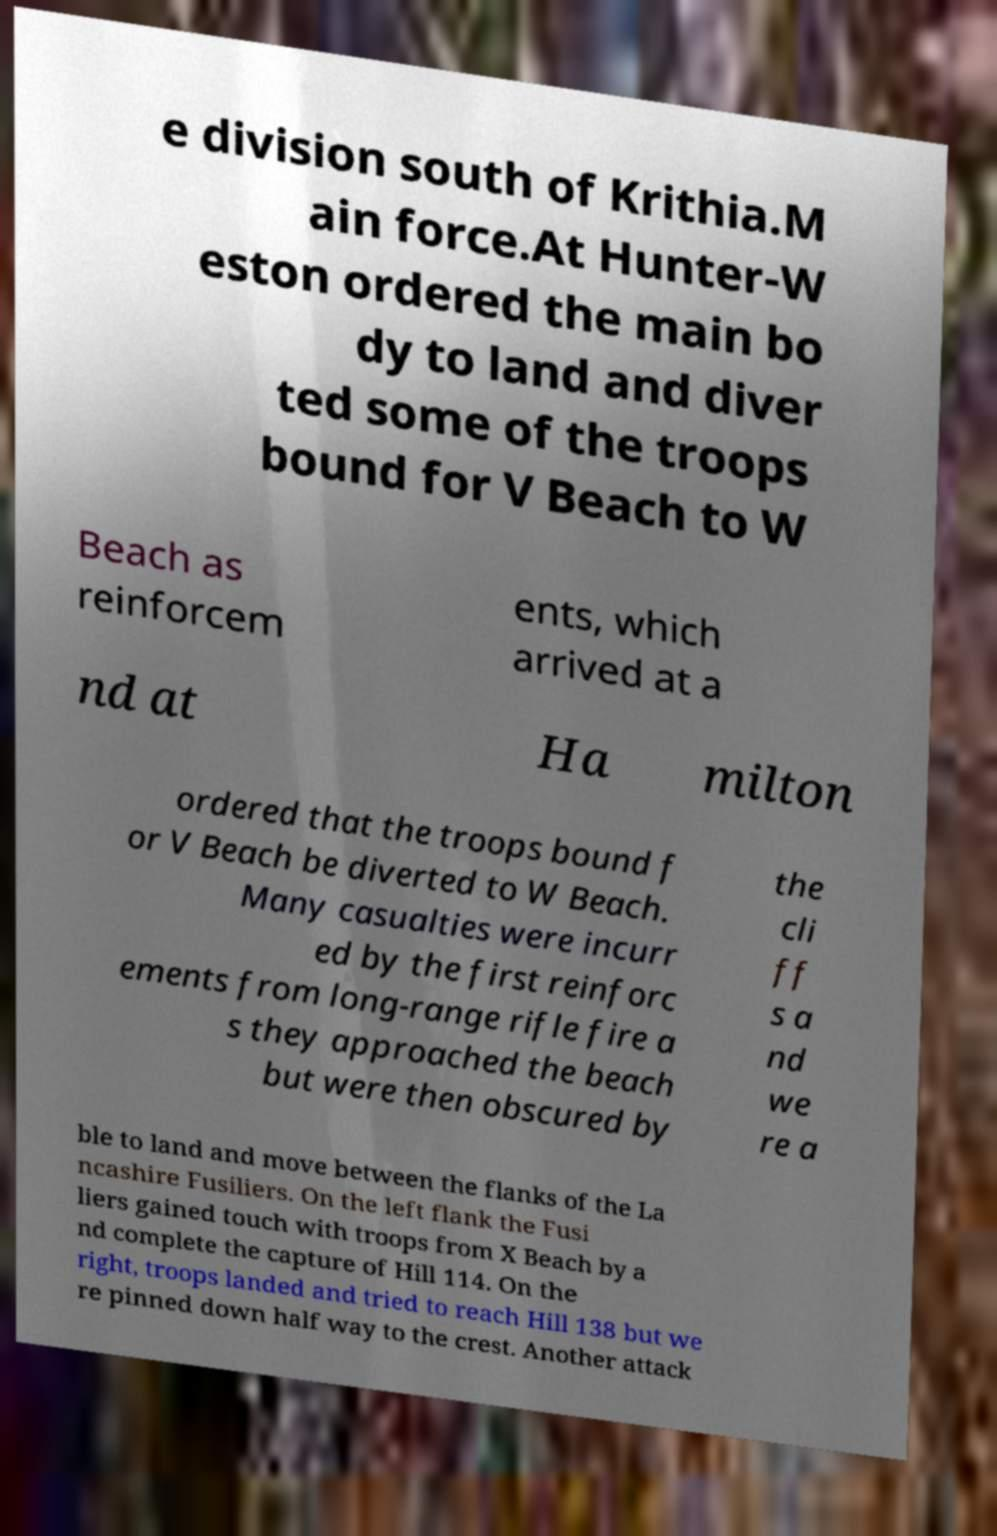I need the written content from this picture converted into text. Can you do that? e division south of Krithia.M ain force.At Hunter-W eston ordered the main bo dy to land and diver ted some of the troops bound for V Beach to W Beach as reinforcem ents, which arrived at a nd at Ha milton ordered that the troops bound f or V Beach be diverted to W Beach. Many casualties were incurr ed by the first reinforc ements from long-range rifle fire a s they approached the beach but were then obscured by the cli ff s a nd we re a ble to land and move between the flanks of the La ncashire Fusiliers. On the left flank the Fusi liers gained touch with troops from X Beach by a nd complete the capture of Hill 114. On the right, troops landed and tried to reach Hill 138 but we re pinned down half way to the crest. Another attack 